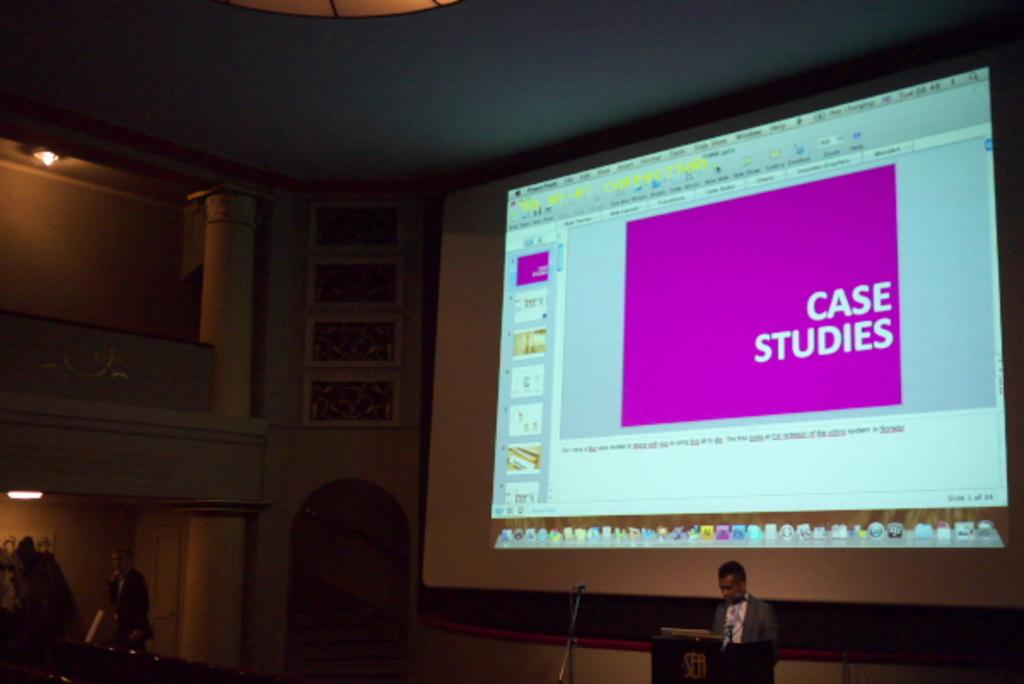<image>
Provide a brief description of the given image. A man stands at a podium, behind him a power point presentation starts with case studies. 